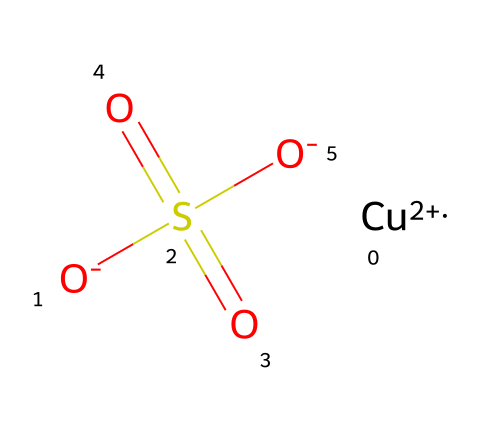What is the central metal in this chemical? The SMILES representation shows "[Cu+2]" indicating that the central metal atom is copper.
Answer: copper How many sulfate groups are present in the chemical? The structure contains "S(=O)(=O)[O-]", which represents one sulfate group.
Answer: one What is the oxidation state of copper in this compound? The SMILES indicates "[Cu+2]", meaning that copper is in the +2 oxidation state.
Answer: +2 What type of bond connects sulfur to the oxygen atoms in the sulfate group? The structure shows sulfur bonded to three oxygen atoms, two of which are double-bonded (as indicated by the “=O”) and one single-bonded. This indicates covalent bonds between sulfur and oxygen.
Answer: covalent Identify the primary usage of this chemical. Copper sulfate is widely recognized as a fungicide used in gardens to control fungal diseases.
Answer: fungicide Which ions are present alongside copper in this chemical? The structure shows two negatively charged oxygen atoms represented as "[O-]", indicating that sulfate ions are present along with copper.
Answer: sulfate ions Why is copper sulfate effective as a fungicide? Copper ions interfere with enzyme activities in fungi, disrupting their metabolism and preventing growth, making copper sulfate effective against fungal infections.
Answer: enzyme interference 